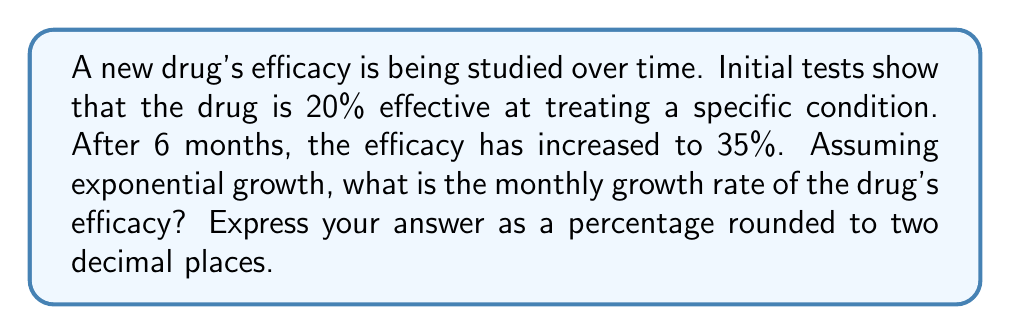Show me your answer to this math problem. To solve this problem, we'll use the exponential growth formula:

$$A = P(1 + r)^t$$

Where:
$A$ = Final amount (35% efficacy)
$P$ = Initial amount (20% efficacy)
$r$ = Monthly growth rate (what we're solving for)
$t$ = Time period (6 months)

1) Let's plug in the known values:

   $$0.35 = 0.20(1 + r)^6$$

2) Divide both sides by 0.20:

   $$1.75 = (1 + r)^6$$

3) Take the 6th root of both sides:

   $$\sqrt[6]{1.75} = 1 + r$$

4) Subtract 1 from both sides:

   $$\sqrt[6]{1.75} - 1 = r$$

5) Calculate the value:

   $$r \approx 0.0961$$

6) Convert to a percentage:

   $$r \approx 9.61\%$$

7) Round to two decimal places:

   $$r \approx 9.61\%$$

This means the drug's efficacy is growing by approximately 9.61% each month.
Answer: 9.61% 